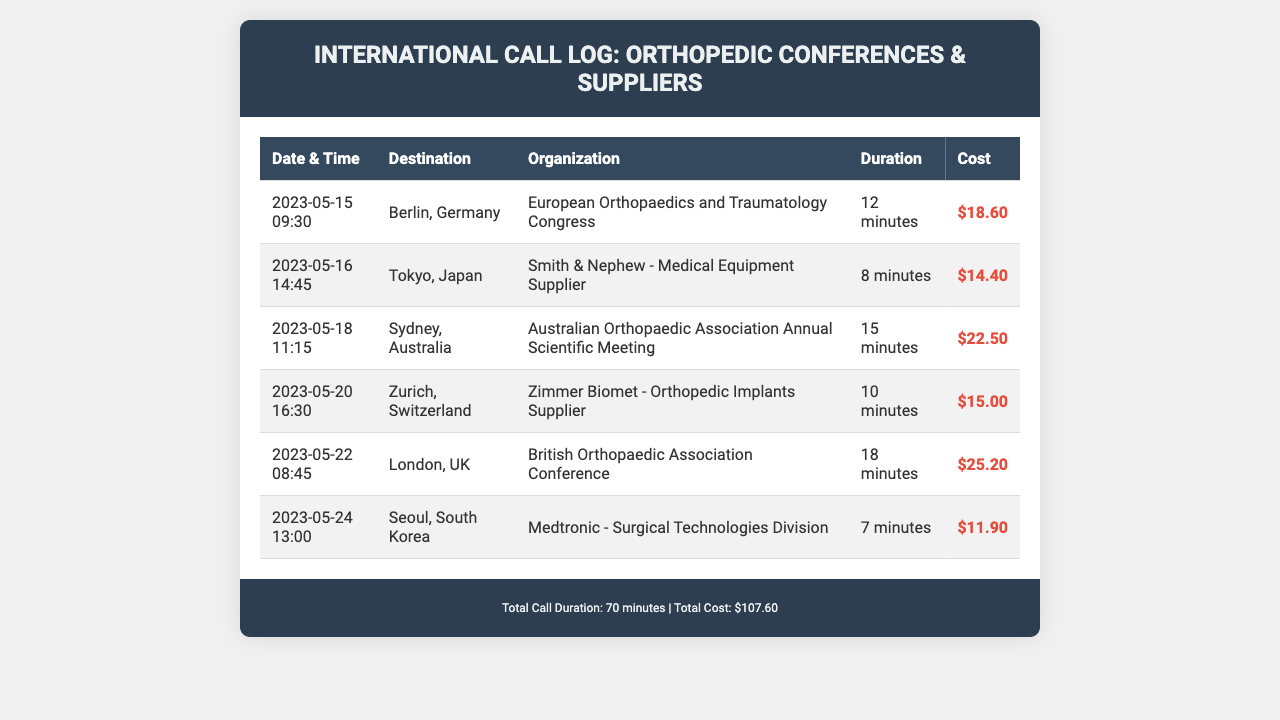What is the total cost of all calls? The total cost is listed in the footer of the document, which sums up the costs of all calls made in the log.
Answer: $107.60 What was the longest call duration? The call with the longest duration can be found by comparing the duration of each entry in the table.
Answer: 18 minutes What organization did the call to London relate to? The organization for the call to London is specified in the corresponding row of the table.
Answer: British Orthopaedic Association Conference Which country had the second to last call in the log? Reviewing the order of the calls based on the date and time will reveal the second to last entry.
Answer: Seoul, South Korea How much did the call to Zurich cost? The cost of the call to Zurich is shown in the table under the corresponding entry for that destination.
Answer: $15.00 Which country was called on May 16, 2023? The date of the call can be found in the corresponding entry, which will indicate the specific destination.
Answer: Tokyo, Japan What is the total call duration? The total duration is listed in the footer and is the sum of all call durations recorded in the log.
Answer: 70 minutes Which medical supply vendor was contacted from Tokyo? The vendor related to the call in Tokyo is specified in the corresponding entry of the table.
Answer: Smith & Nephew - Medical Equipment Supplier 